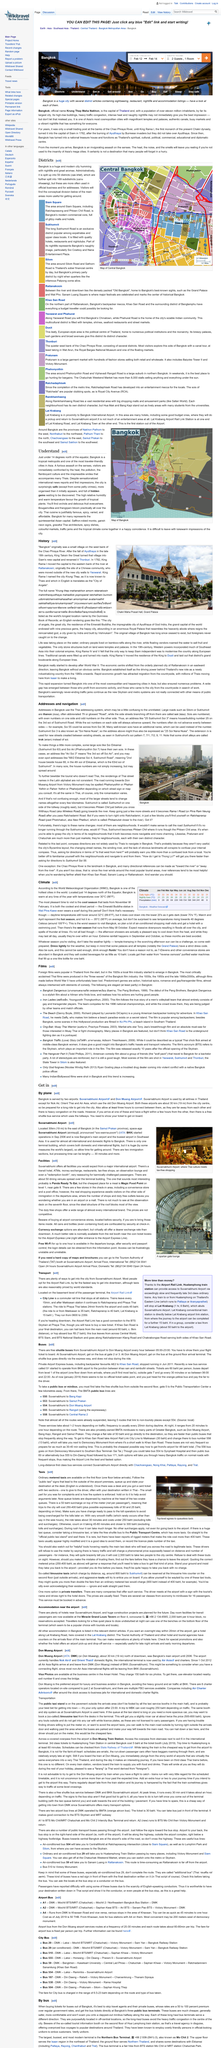Point out several critical features in this image. The Tourism Authority of Thailand (TAT) offers maps and brochures to provide information about the country's tourist destinations. Ordinary metered taxis can be found on the first floor. The image displays red numbers, which represent the daily high temperatures, as stated in the given sentence. Alternative names for short alleys, also known as soi, include trok. The photograph depicts the Chakri Maha Prasat Hall and Grand Palace, which are architectural landmarks located in Bangkok, Thailand. 